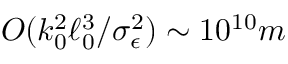Convert formula to latex. <formula><loc_0><loc_0><loc_500><loc_500>O ( k _ { 0 } ^ { 2 } \ell _ { 0 } ^ { 3 } / \sigma _ { \epsilon } ^ { 2 } ) \sim 1 0 ^ { 1 0 } m</formula> 